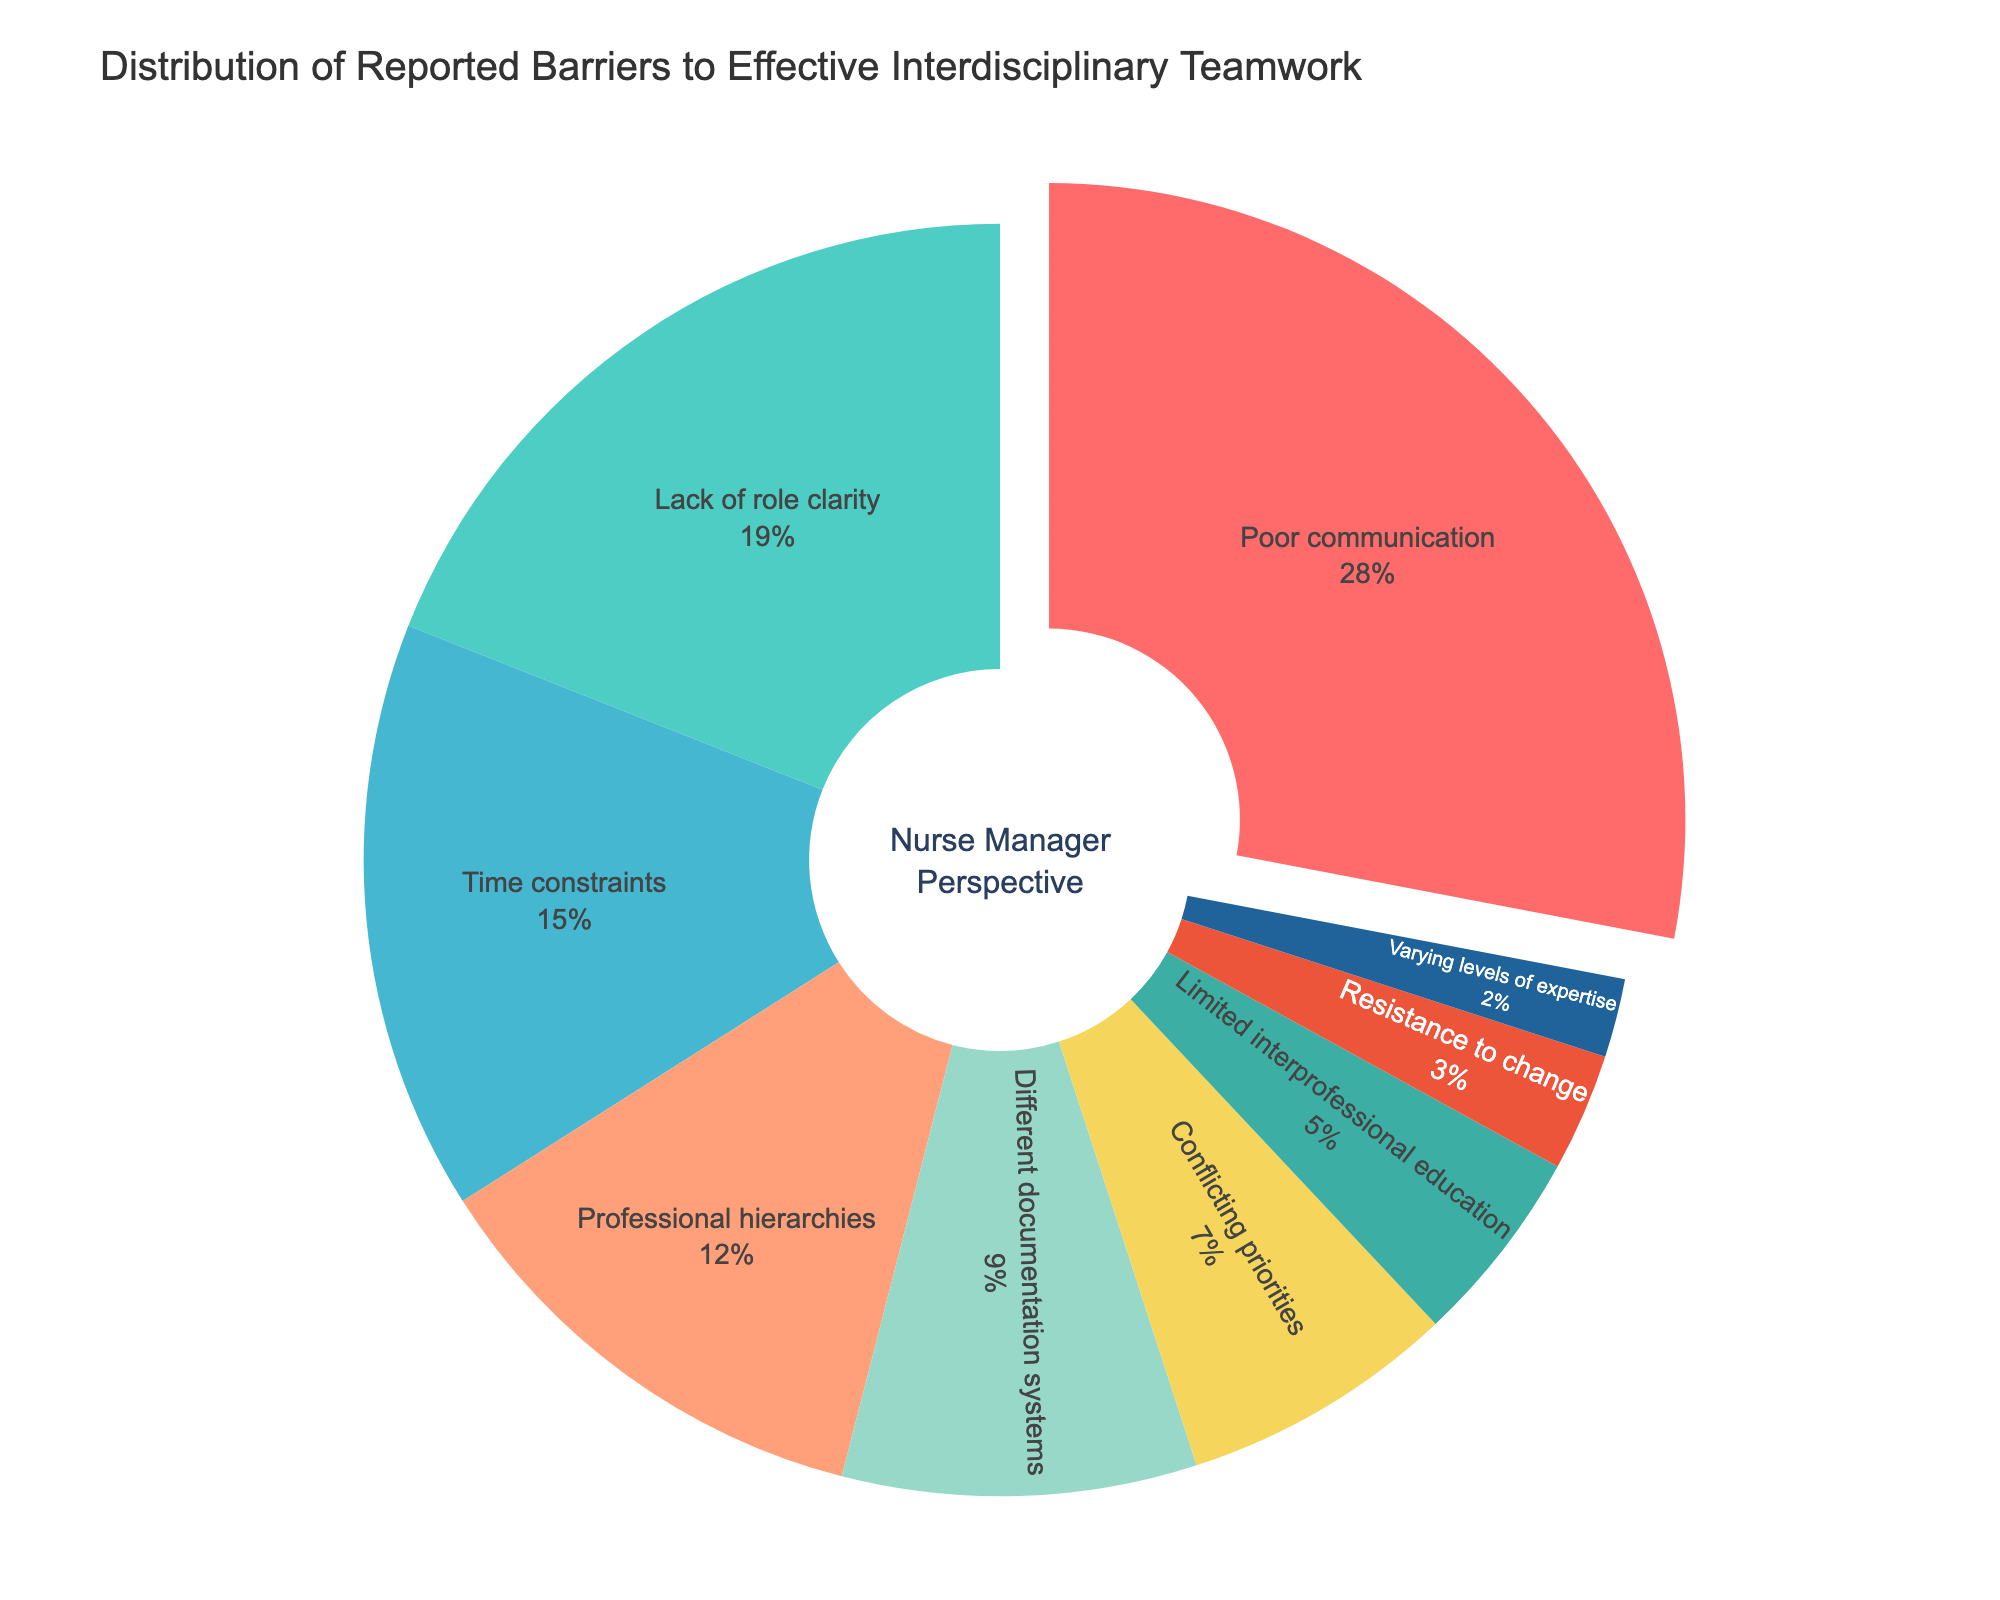What is the most reported barrier to effective interdisciplinary teamwork? The question asks for the highest percentage slice in the pie chart. By looking at the figure, the largest slice represents "Poor communication" at 28%.
Answer: Poor communication Which barrier has a percentage double that of "Conflicting priorities"? "Conflicting priorities" is reported at 7%. Double of 7% is 14%. The slice greater than or equal to 14% closest to this value is "Lack of role clarity," which is at 19%.
Answer: Lack of role clarity What percentage of barriers is due to "Professional hierarchies" and "Different documentation systems" combined? "Professional hierarchies" is 12%, and "Different documentation systems" is 9%. Adding these together, 12% + 9% = 21%.
Answer: 21% How does the percentage of "Lack of role clarity" compare to "Time constraints"? "Lack of role clarity" is at 19%, while "Time constraints" is at 15%. Hence, "Lack of role clarity" is greater than "Time constraints."
Answer: Lack of role clarity is greater Which barrier in the chart has the smallest percentage, and what color is it represented by? The smallest percentage reported is "Varying levels of expertise" at 2%. This slice is represented by a color (check the visual representation and mention the color).
Answer: Varying levels of expertise, color is dark blue 